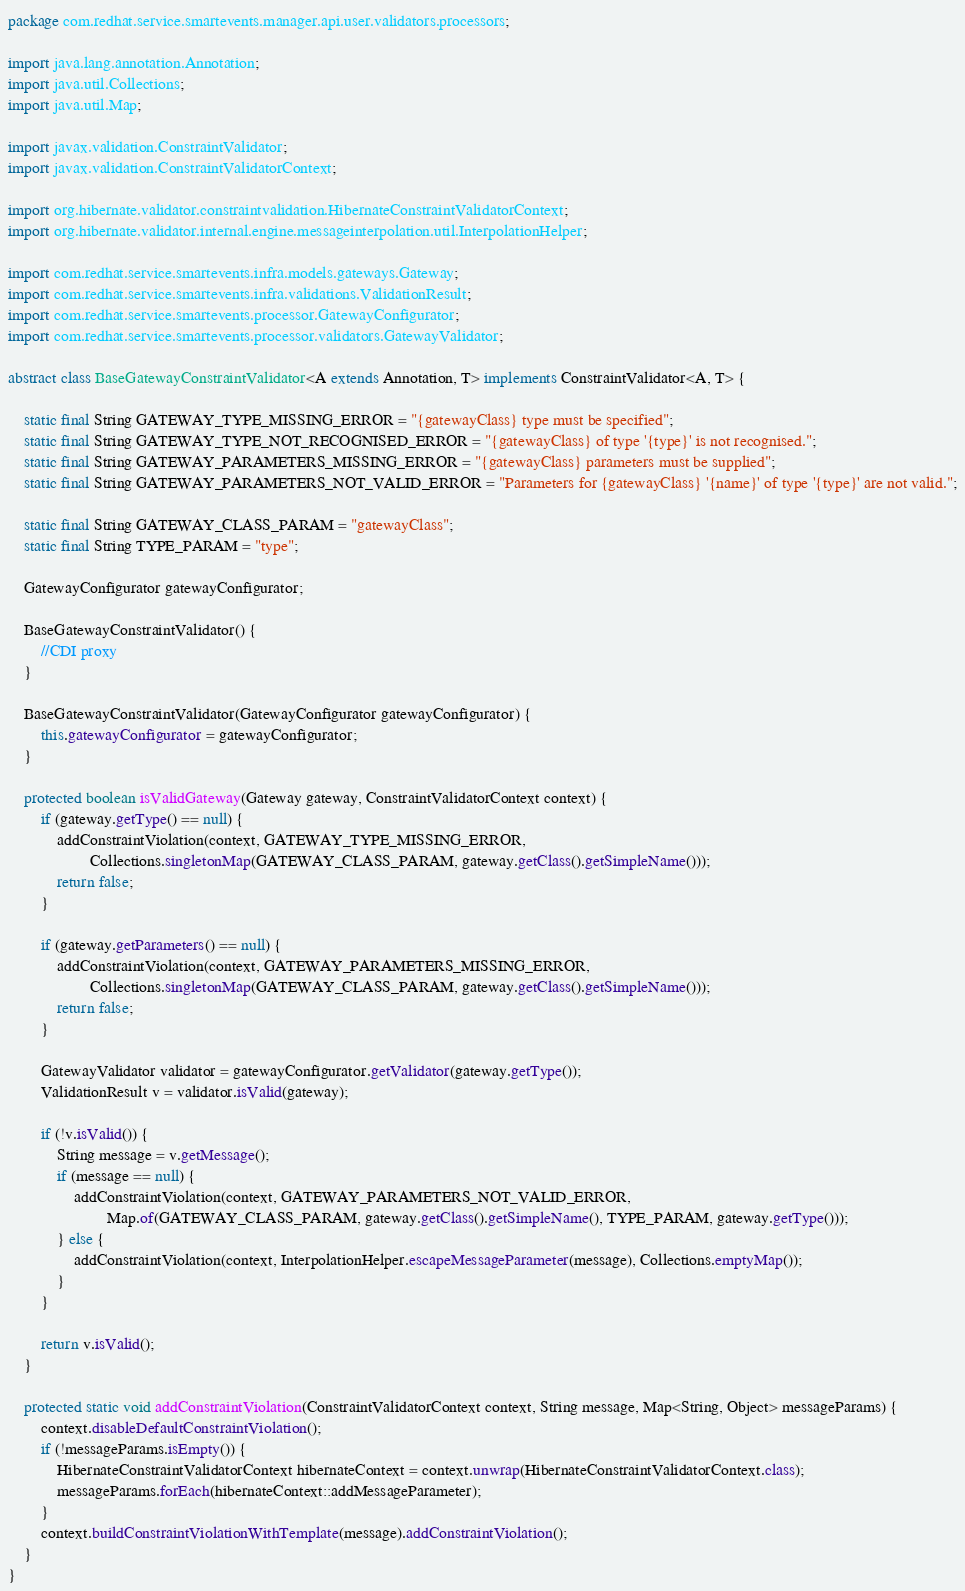<code> <loc_0><loc_0><loc_500><loc_500><_Java_>package com.redhat.service.smartevents.manager.api.user.validators.processors;

import java.lang.annotation.Annotation;
import java.util.Collections;
import java.util.Map;

import javax.validation.ConstraintValidator;
import javax.validation.ConstraintValidatorContext;

import org.hibernate.validator.constraintvalidation.HibernateConstraintValidatorContext;
import org.hibernate.validator.internal.engine.messageinterpolation.util.InterpolationHelper;

import com.redhat.service.smartevents.infra.models.gateways.Gateway;
import com.redhat.service.smartevents.infra.validations.ValidationResult;
import com.redhat.service.smartevents.processor.GatewayConfigurator;
import com.redhat.service.smartevents.processor.validators.GatewayValidator;

abstract class BaseGatewayConstraintValidator<A extends Annotation, T> implements ConstraintValidator<A, T> {

    static final String GATEWAY_TYPE_MISSING_ERROR = "{gatewayClass} type must be specified";
    static final String GATEWAY_TYPE_NOT_RECOGNISED_ERROR = "{gatewayClass} of type '{type}' is not recognised.";
    static final String GATEWAY_PARAMETERS_MISSING_ERROR = "{gatewayClass} parameters must be supplied";
    static final String GATEWAY_PARAMETERS_NOT_VALID_ERROR = "Parameters for {gatewayClass} '{name}' of type '{type}' are not valid.";

    static final String GATEWAY_CLASS_PARAM = "gatewayClass";
    static final String TYPE_PARAM = "type";

    GatewayConfigurator gatewayConfigurator;

    BaseGatewayConstraintValidator() {
        //CDI proxy
    }

    BaseGatewayConstraintValidator(GatewayConfigurator gatewayConfigurator) {
        this.gatewayConfigurator = gatewayConfigurator;
    }

    protected boolean isValidGateway(Gateway gateway, ConstraintValidatorContext context) {
        if (gateway.getType() == null) {
            addConstraintViolation(context, GATEWAY_TYPE_MISSING_ERROR,
                    Collections.singletonMap(GATEWAY_CLASS_PARAM, gateway.getClass().getSimpleName()));
            return false;
        }

        if (gateway.getParameters() == null) {
            addConstraintViolation(context, GATEWAY_PARAMETERS_MISSING_ERROR,
                    Collections.singletonMap(GATEWAY_CLASS_PARAM, gateway.getClass().getSimpleName()));
            return false;
        }

        GatewayValidator validator = gatewayConfigurator.getValidator(gateway.getType());
        ValidationResult v = validator.isValid(gateway);

        if (!v.isValid()) {
            String message = v.getMessage();
            if (message == null) {
                addConstraintViolation(context, GATEWAY_PARAMETERS_NOT_VALID_ERROR,
                        Map.of(GATEWAY_CLASS_PARAM, gateway.getClass().getSimpleName(), TYPE_PARAM, gateway.getType()));
            } else {
                addConstraintViolation(context, InterpolationHelper.escapeMessageParameter(message), Collections.emptyMap());
            }
        }

        return v.isValid();
    }

    protected static void addConstraintViolation(ConstraintValidatorContext context, String message, Map<String, Object> messageParams) {
        context.disableDefaultConstraintViolation();
        if (!messageParams.isEmpty()) {
            HibernateConstraintValidatorContext hibernateContext = context.unwrap(HibernateConstraintValidatorContext.class);
            messageParams.forEach(hibernateContext::addMessageParameter);
        }
        context.buildConstraintViolationWithTemplate(message).addConstraintViolation();
    }
}
</code> 